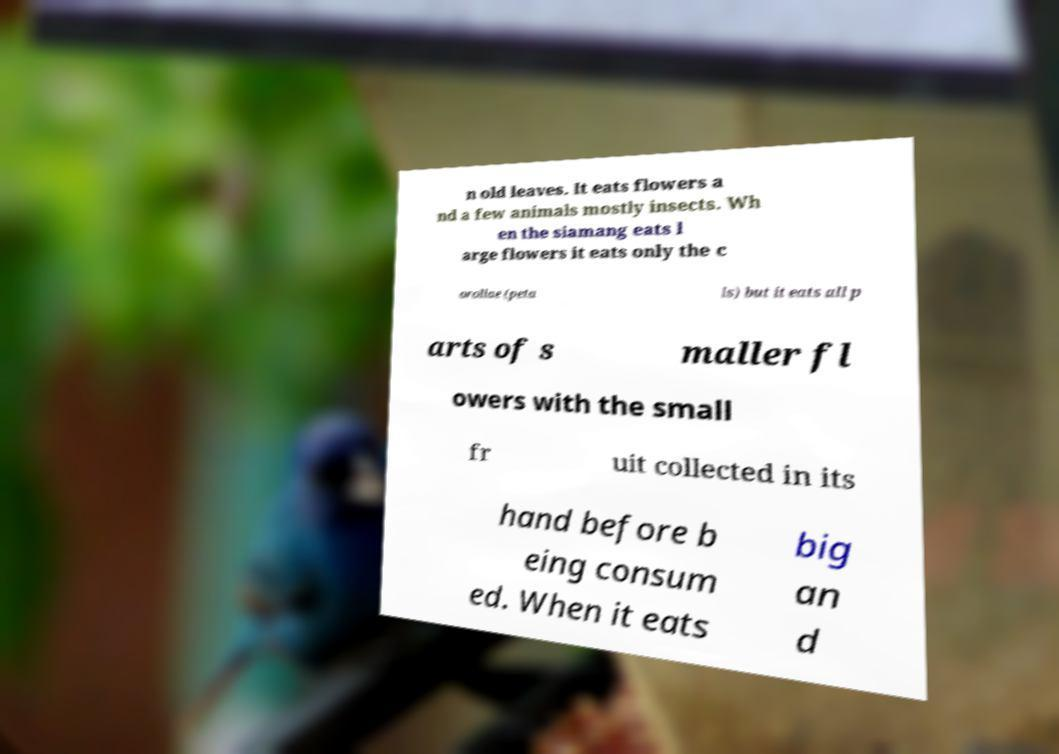Please identify and transcribe the text found in this image. n old leaves. It eats flowers a nd a few animals mostly insects. Wh en the siamang eats l arge flowers it eats only the c orollae (peta ls) but it eats all p arts of s maller fl owers with the small fr uit collected in its hand before b eing consum ed. When it eats big an d 